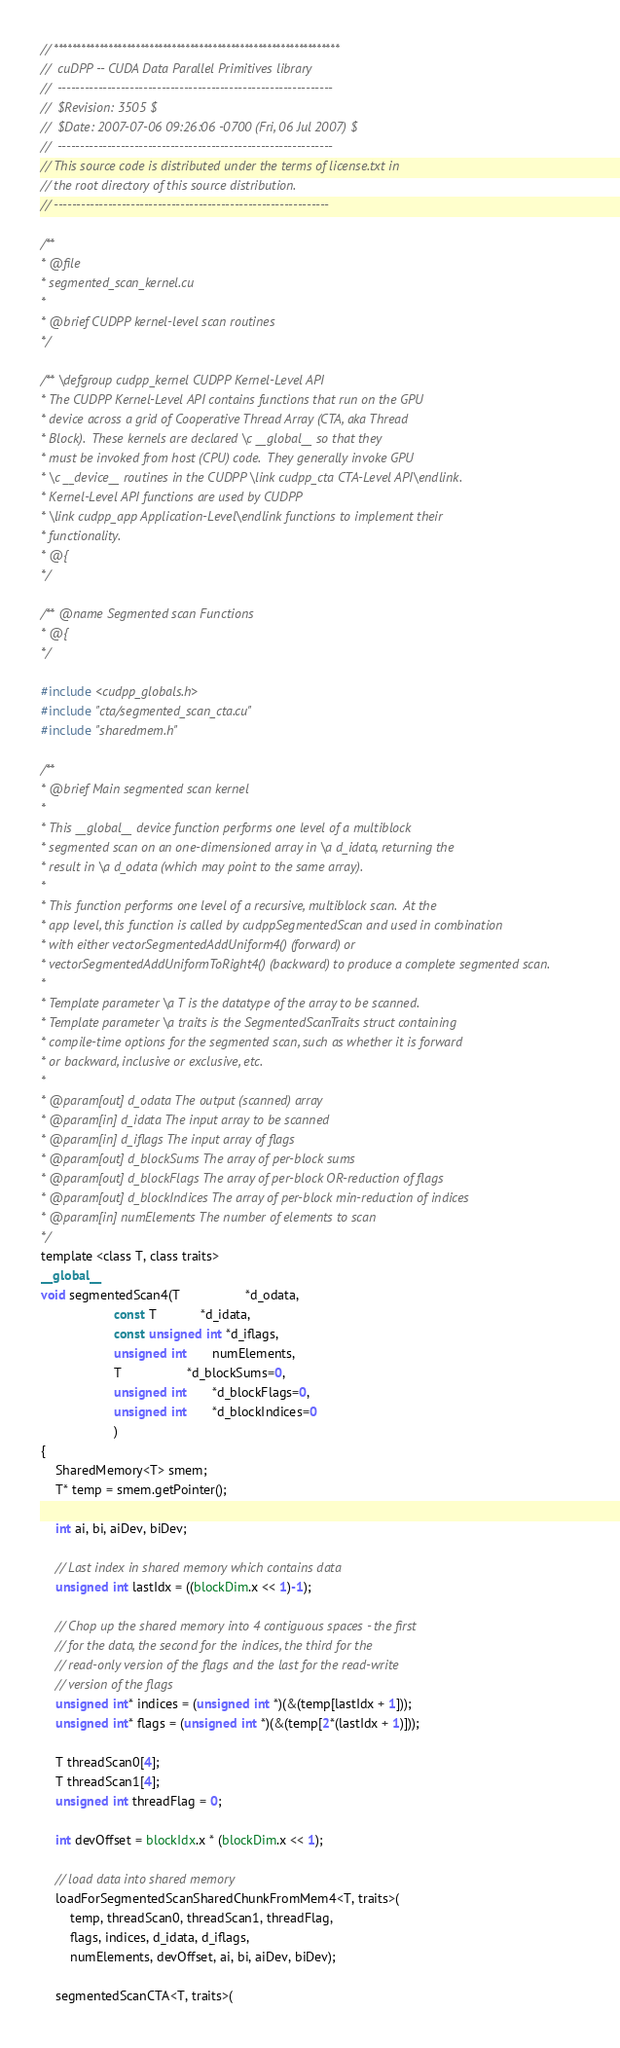Convert code to text. <code><loc_0><loc_0><loc_500><loc_500><_Cuda_>// ***************************************************************
//  cuDPP -- CUDA Data Parallel Primitives library
//  -------------------------------------------------------------
//  $Revision: 3505 $
//  $Date: 2007-07-06 09:26:06 -0700 (Fri, 06 Jul 2007) $
//  -------------------------------------------------------------
// This source code is distributed under the terms of license.txt in
// the root directory of this source distribution.
// ------------------------------------------------------------- 

/**
* @file
* segmented_scan_kernel.cu
*
* @brief CUDPP kernel-level scan routines
*/

/** \defgroup cudpp_kernel CUDPP Kernel-Level API
* The CUDPP Kernel-Level API contains functions that run on the GPU 
* device across a grid of Cooperative Thread Array (CTA, aka Thread
* Block).  These kernels are declared \c __global__ so that they 
* must be invoked from host (CPU) code.  They generally invoke GPU 
* \c __device__ routines in the CUDPP \link cudpp_cta CTA-Level API\endlink. 
* Kernel-Level API functions are used by CUDPP 
* \link cudpp_app Application-Level\endlink functions to implement their 
* functionality.
* @{
*/

/** @name Segmented scan Functions
* @{
*/

#include <cudpp_globals.h>
#include "cta/segmented_scan_cta.cu"
#include "sharedmem.h"

/**
* @brief Main segmented scan kernel
*
* This __global__ device function performs one level of a multiblock 
* segmented scan on an one-dimensioned array in \a d_idata, returning the 
* result in \a d_odata (which may point to the same array).    
* 
* This function performs one level of a recursive, multiblock scan.  At the 
* app level, this function is called by cudppSegmentedScan and used in combination 
* with either vectorSegmentedAddUniform4() (forward) or 
* vectorSegmentedAddUniformToRight4() (backward) to produce a complete segmented scan.
*
* Template parameter \a T is the datatype of the array to be scanned. 
* Template parameter \a traits is the SegmentedScanTraits struct containing 
* compile-time options for the segmented scan, such as whether it is forward 
* or backward, inclusive or exclusive, etc.
* 
* @param[out] d_odata The output (scanned) array
* @param[in] d_idata The input array to be scanned
* @param[in] d_iflags The input array of flags
* @param[out] d_blockSums The array of per-block sums
* @param[out] d_blockFlags The array of per-block OR-reduction of flags
* @param[out] d_blockIndices The array of per-block min-reduction of indices
* @param[in] numElements The number of elements to scan
*/
template <class T, class traits>
__global__ 
void segmentedScan4(T                  *d_odata, 
                    const T            *d_idata, 
                    const unsigned int *d_iflags,
                    unsigned int       numElements,
                    T                  *d_blockSums=0,
                    unsigned int       *d_blockFlags=0,
                    unsigned int       *d_blockIndices=0
                    )
{
    SharedMemory<T> smem;
    T* temp = smem.getPointer();

    int ai, bi, aiDev, biDev;

    // Last index in shared memory which contains data
    unsigned int lastIdx = ((blockDim.x << 1)-1);

    // Chop up the shared memory into 4 contiguous spaces - the first 
    // for the data, the second for the indices, the third for the 
    // read-only version of the flags and the last for the read-write
    // version of the flags
    unsigned int* indices = (unsigned int *)(&(temp[lastIdx + 1]));
    unsigned int* flags = (unsigned int *)(&(temp[2*(lastIdx + 1)]));

    T threadScan0[4];
    T threadScan1[4];
    unsigned int threadFlag = 0;

    int devOffset = blockIdx.x * (blockDim.x << 1);

    // load data into shared memory
    loadForSegmentedScanSharedChunkFromMem4<T, traits>(
        temp, threadScan0, threadScan1, threadFlag,  
        flags, indices, d_idata, d_iflags, 
        numElements, devOffset, ai, bi, aiDev, biDev);

    segmentedScanCTA<T, traits>(</code> 